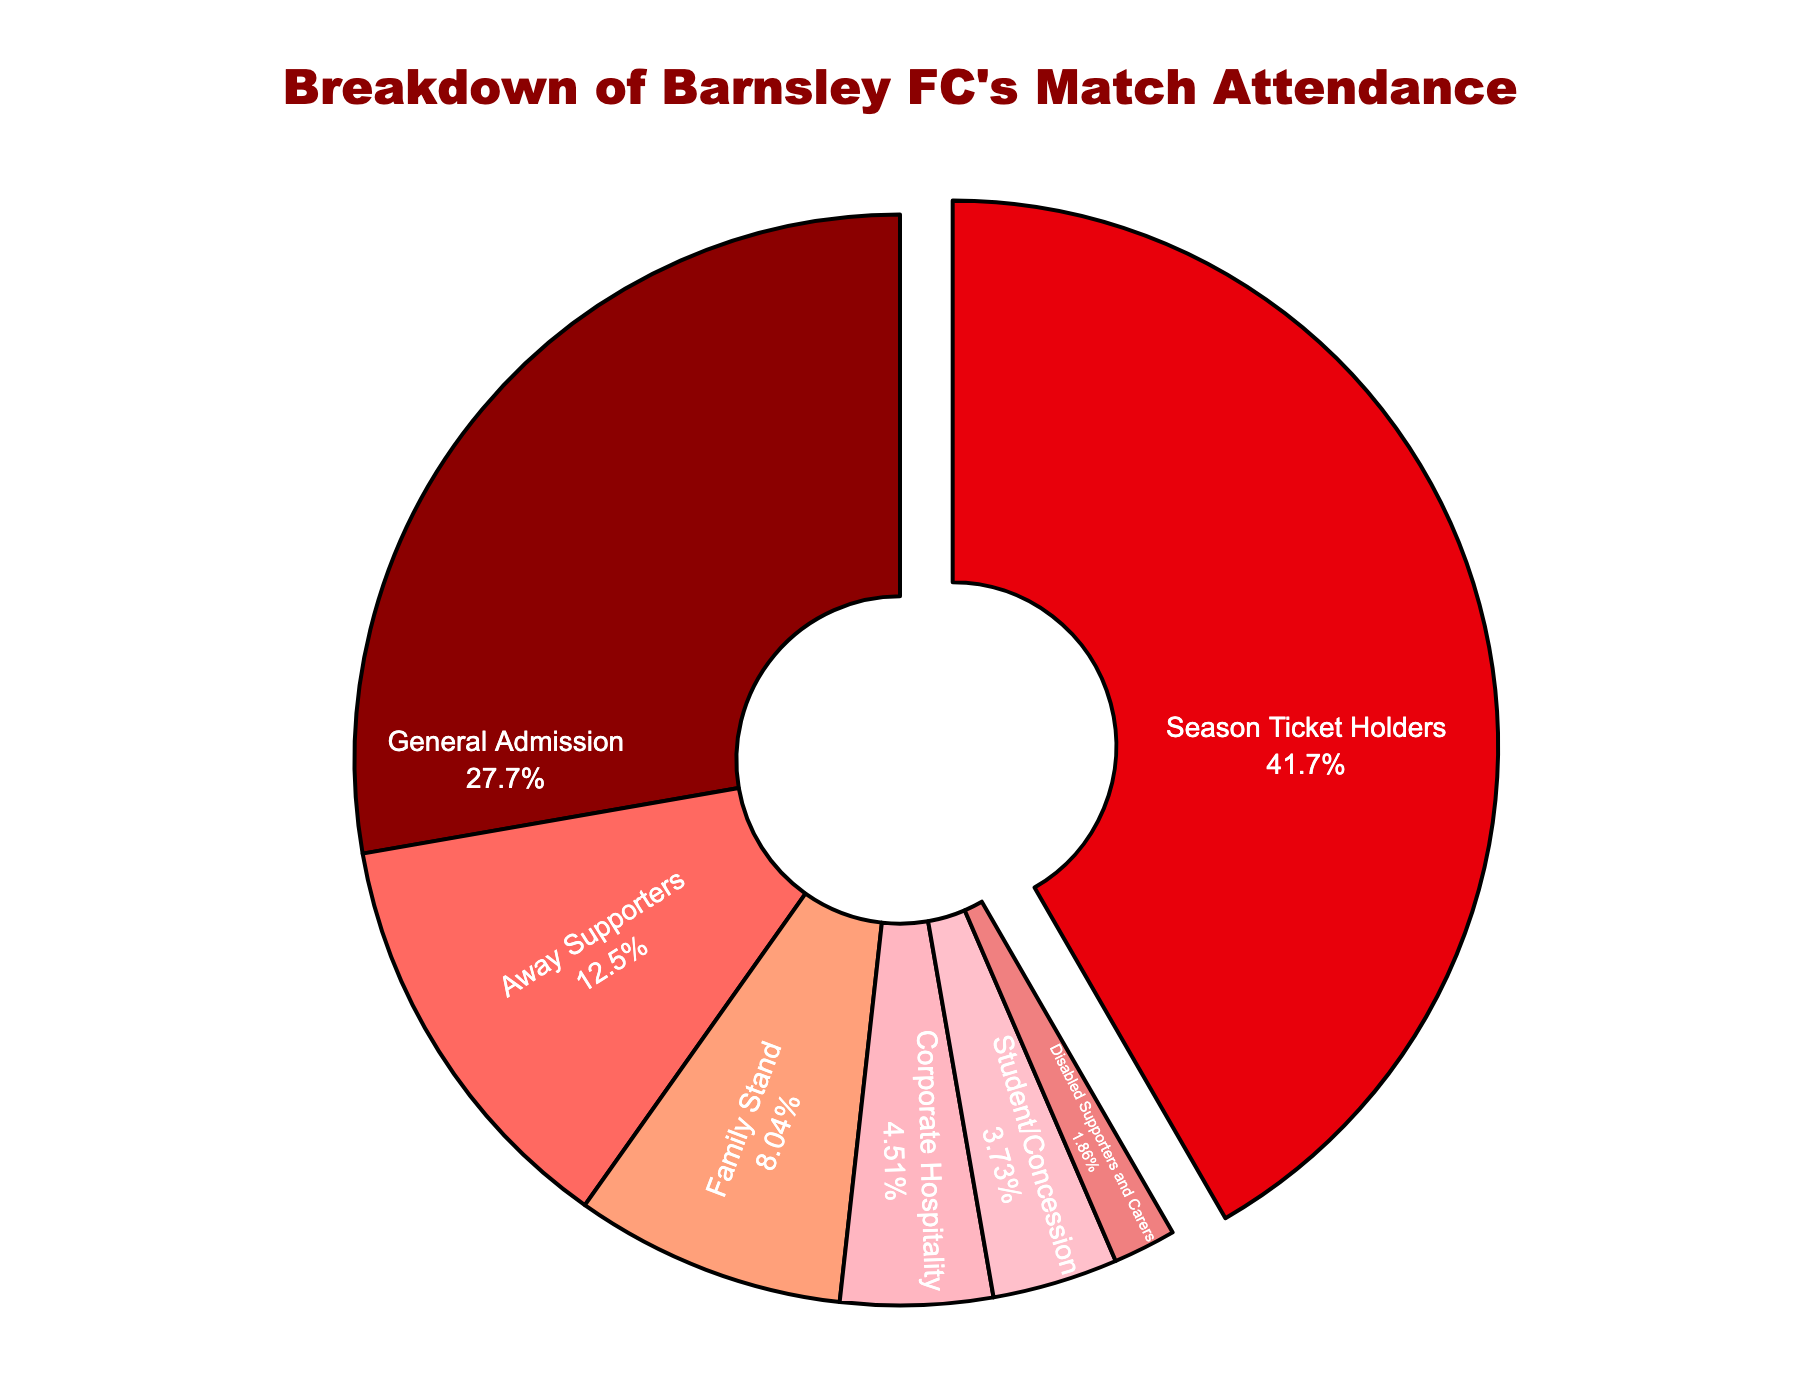Which ticket type has the highest percentage of match attendance? The figure indicates various percentages for each ticket type, with 'Season Ticket Holders' at the highest percentage of 42.5%.
Answer: Season Ticket Holders What is the combined percentage of General Admission and Away Supporters? The figure shows that General Admission is 28.3% and Away Supporters is 12.7%. Adding these together gives 28.3 + 12.7 = 41.0%.
Answer: 41.0% How does the percentage of Family Stand compare to that of Corporate Hospitality? The percentage for Family Stand is 8.2% and for Corporate Hospitality is 4.6%. Comparing these, Family Stand has a higher percentage than Corporate Hospitality.
Answer: Family Stand has a higher percentage Which ticket type contributes the least to match attendance? Observing the figure, 'Disabled Supporters and Carers' has the smallest percentage at 1.9%.
Answer: Disabled Supporters and Carers What is the total percentage of groups making up less than 10% each? Ticket types with less than 10% are Away Supporters (12.7%), Family Stand (8.2%), Corporate Hospitality (4.6%), Student/Concession (3.8%), and Disabled Supporters and Carers (1.9%). Sum of these: 8.2 + 4.6 + 3.8 + 1.9 = 18.5%.
Answer: 18.5% Is the percentage of General Admission greater than the combined percentage of Student/Concession and Disabled Supporters and Carers? The figure shows General Admission at 28.3%. The combined percentage of Student/Concession (3.8%) and Disabled Supporters and Carers (1.9%) is 3.8 + 1.9 = 5.7%. Since 28.3% is greater than 5.7%, the answer is yes.
Answer: Yes What is the difference in percentage points between Season Ticket Holders and General Admission? Season Ticket Holders have 42.5% and General Admission has 28.3%. The difference is 42.5 - 28.3 = 14.2 percentage points.
Answer: 14.2 Which groups make up more than 25% of attendance combined? The groups with over 25% combined are Season Ticket Holders (42.5%) and General Admission (28.3%). Adding these together, 42.5 + 28.3 = 70.8%.
Answer: Season Ticket Holders and General Admission 